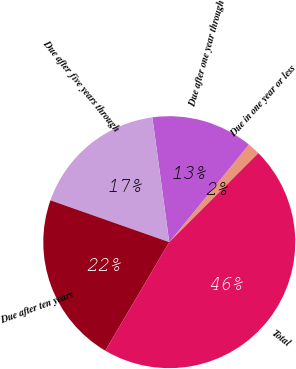<chart> <loc_0><loc_0><loc_500><loc_500><pie_chart><fcel>Due in one year or less<fcel>Due after one year through<fcel>Due after five years through<fcel>Due after ten years<fcel>Total<nl><fcel>1.61%<fcel>13.04%<fcel>17.47%<fcel>21.91%<fcel>45.97%<nl></chart> 